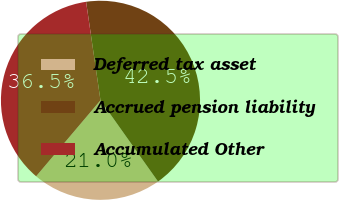Convert chart. <chart><loc_0><loc_0><loc_500><loc_500><pie_chart><fcel>Deferred tax asset<fcel>Accrued pension liability<fcel>Accumulated Other<nl><fcel>20.99%<fcel>42.5%<fcel>36.51%<nl></chart> 